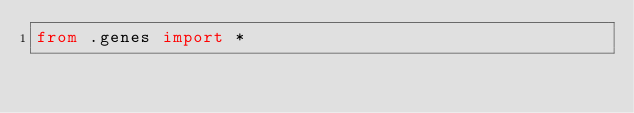<code> <loc_0><loc_0><loc_500><loc_500><_Python_>from .genes import *</code> 